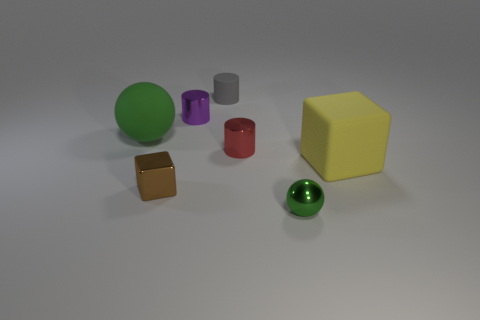What is the material of the other ball that is the same color as the metal ball?
Your answer should be very brief. Rubber. Do the large object to the left of the tiny green ball and the small sphere have the same color?
Provide a short and direct response. Yes. What size is the yellow matte object that is the same shape as the small brown shiny thing?
Offer a very short reply. Large. Is the material of the block that is on the left side of the tiny green sphere the same as the sphere that is on the right side of the small rubber object?
Offer a very short reply. Yes. Is the number of tiny matte cylinders to the right of the yellow matte thing less than the number of big blue metal spheres?
Your response must be concise. No. There is a metal thing that is the same shape as the large yellow rubber object; what color is it?
Offer a very short reply. Brown. There is a green thing behind the red metal thing; is its size the same as the shiny block?
Your answer should be compact. No. How big is the matte object in front of the green sphere that is to the left of the purple metal thing?
Ensure brevity in your answer.  Large. Is the material of the small gray object the same as the green thing in front of the tiny brown metallic block?
Provide a succinct answer. No. Is the number of tiny objects that are in front of the small red thing less than the number of gray objects that are left of the tiny metal block?
Your response must be concise. No. 